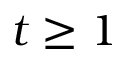Convert formula to latex. <formula><loc_0><loc_0><loc_500><loc_500>t \geq 1</formula> 